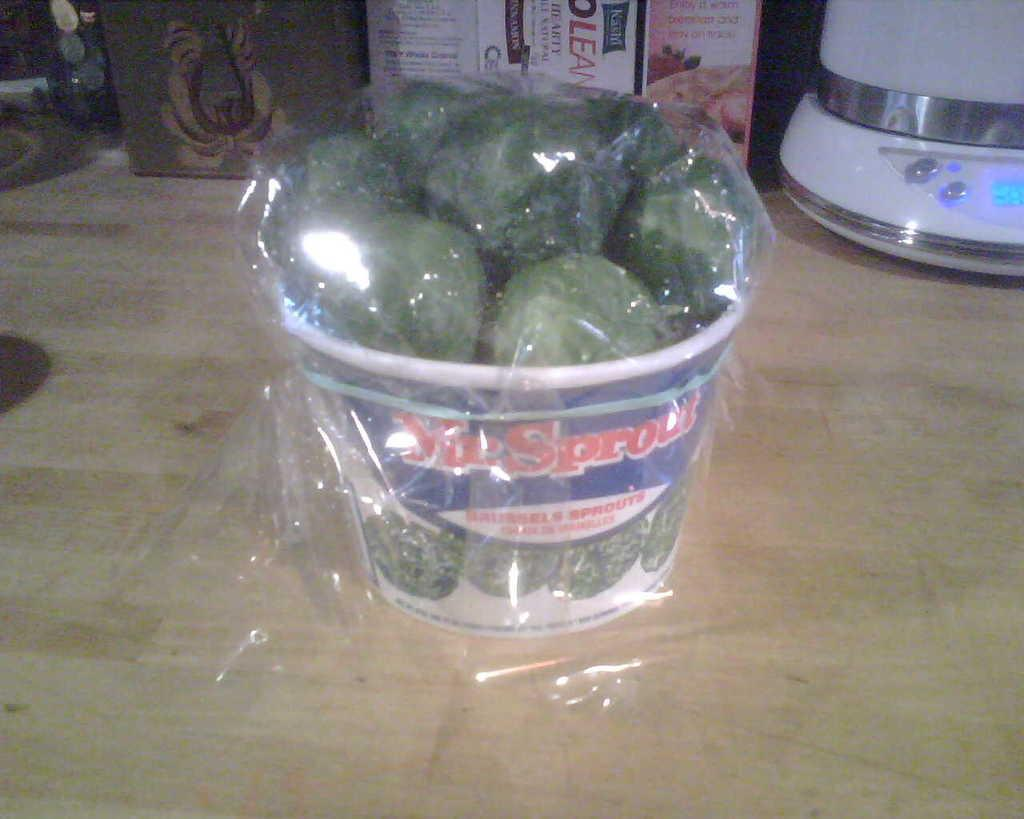Provide a one-sentence caption for the provided image. A bucket of Sprouts sitting on a kitchen counter. 